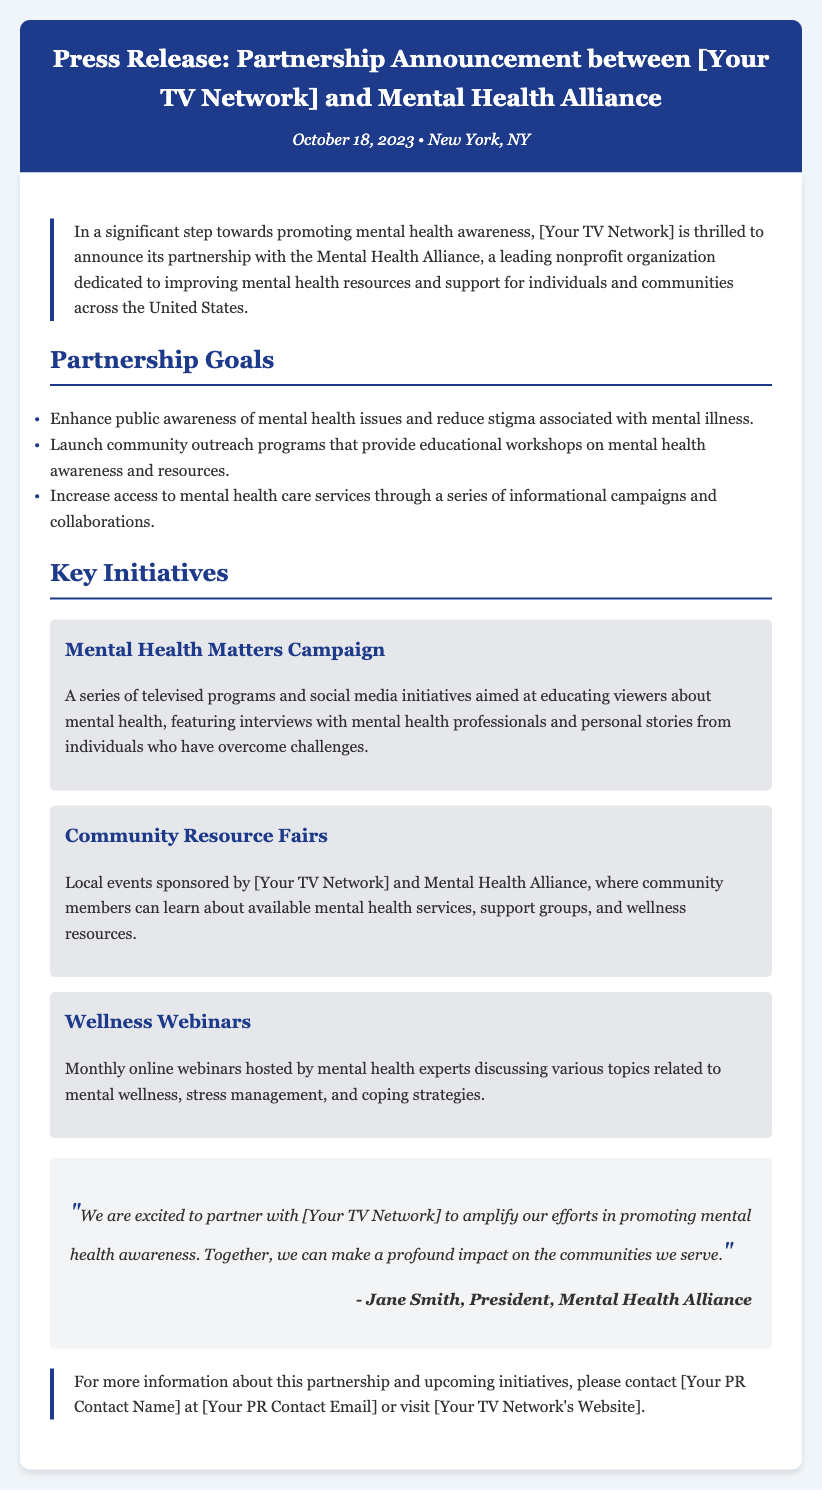What is the name of the partnership announced? The partnership announced is between [Your TV Network] and the Mental Health Alliance.
Answer: [Your TV Network] and Mental Health Alliance When was the press release issued? The date mentioned in the document for the press release is October 18, 2023.
Answer: October 18, 2023 What is one goal of the partnership? One of the goals is to enhance public awareness of mental health issues and reduce stigma associated with mental illness.
Answer: Enhance public awareness What is the title of the campaign mentioned? The campaign mentioned is called the Mental Health Matters Campaign.
Answer: Mental Health Matters Campaign Who is quoted in the document? The document includes a quote from Jane Smith, President of the Mental Health Alliance.
Answer: Jane Smith What type of events will the Community Resource Fairs be? They will be local events sponsored by [Your TV Network] and Mental Health Alliance.
Answer: Local events What is one initiative that will be hosted monthly? The initiative that will be hosted monthly is Wellness Webinars.
Answer: Wellness Webinars What is the background color of the header section? The header section has a background color of #1e3a8a.
Answer: #1e3a8a How can someone get more information about the partnership? People can contact [Your PR Contact Name] at [Your PR Contact Email] or visit [Your TV Network's Website].
Answer: [Your PR Contact Name] at [Your PR Contact Email] 